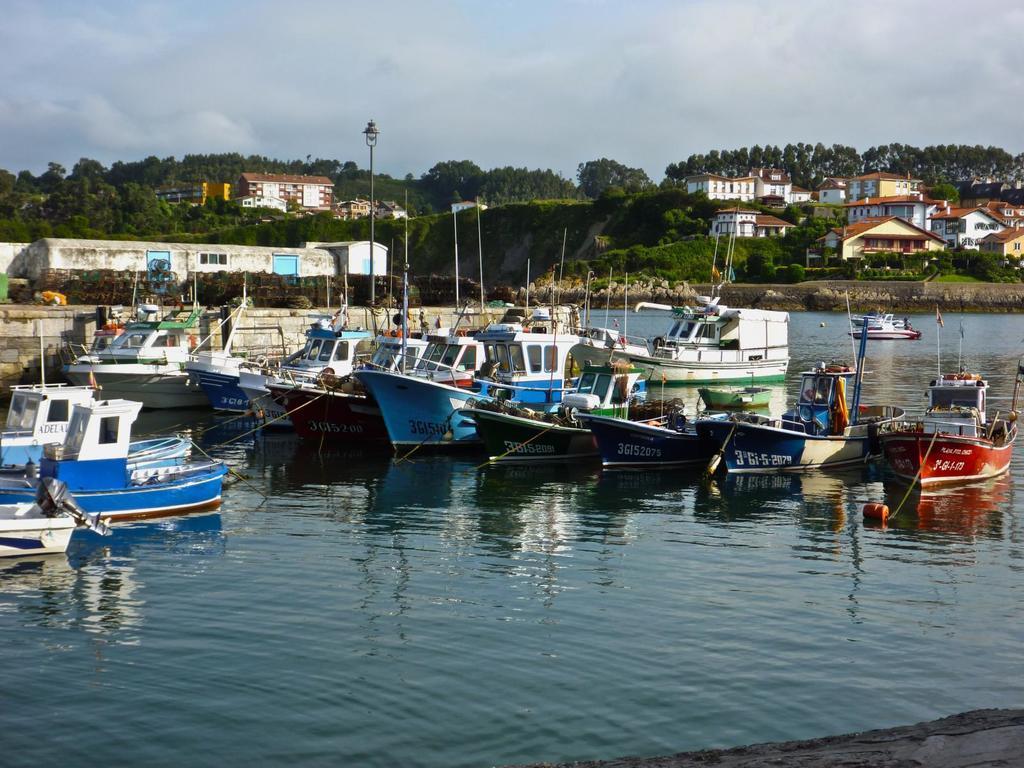In one or two sentences, can you explain what this image depicts? In the picture I can see many boats are floating on the water. In the background, I can see houses, trees, light poles and the cloudy sky. 